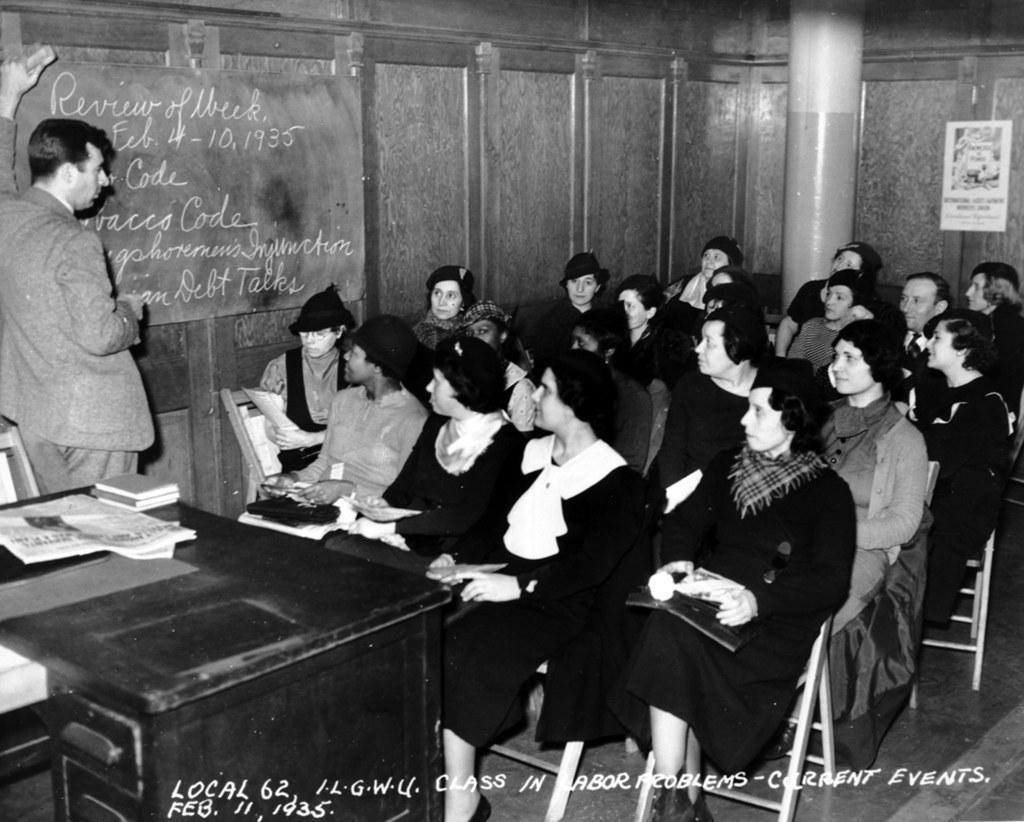Please provide a concise description of this image. There is a group of people. They are sitting on a chair. On the left side we have a one person. His standing. We can see the background there is a table,pillar,cupboard,poster. 